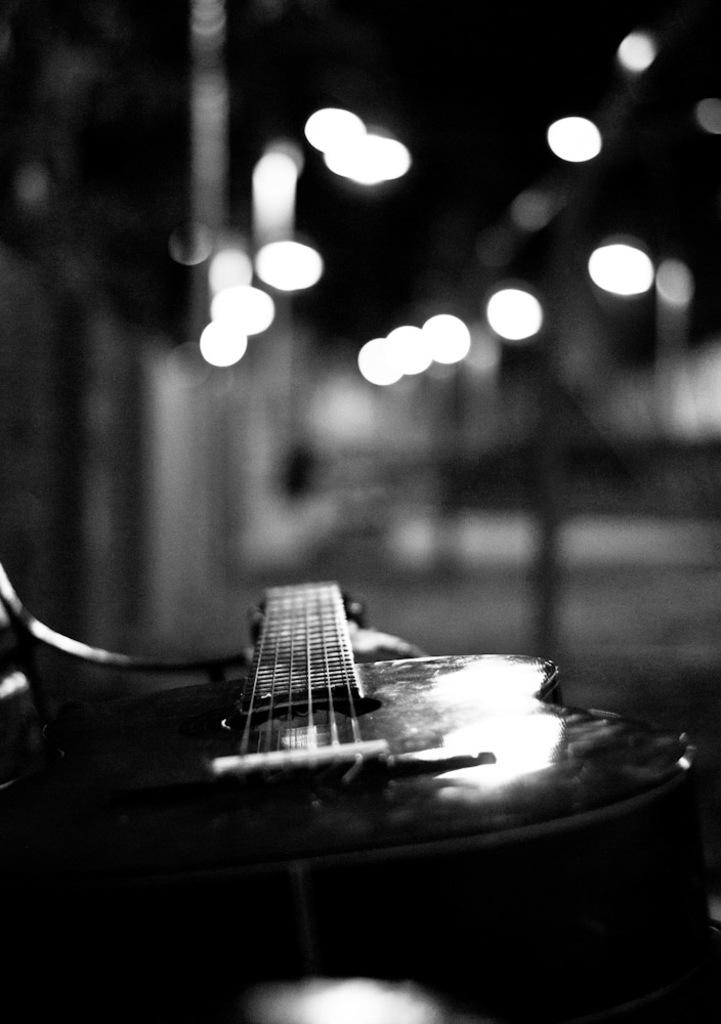What musical instrument is on the ground in the image? There is a guitar on the ground in the image. What else can be seen in the image besides the guitar? There are lights visible in the image. What type of milk is being poured into the guitar in the image? There is no milk or pouring action present in the image; it features a guitar on the ground and lights. 